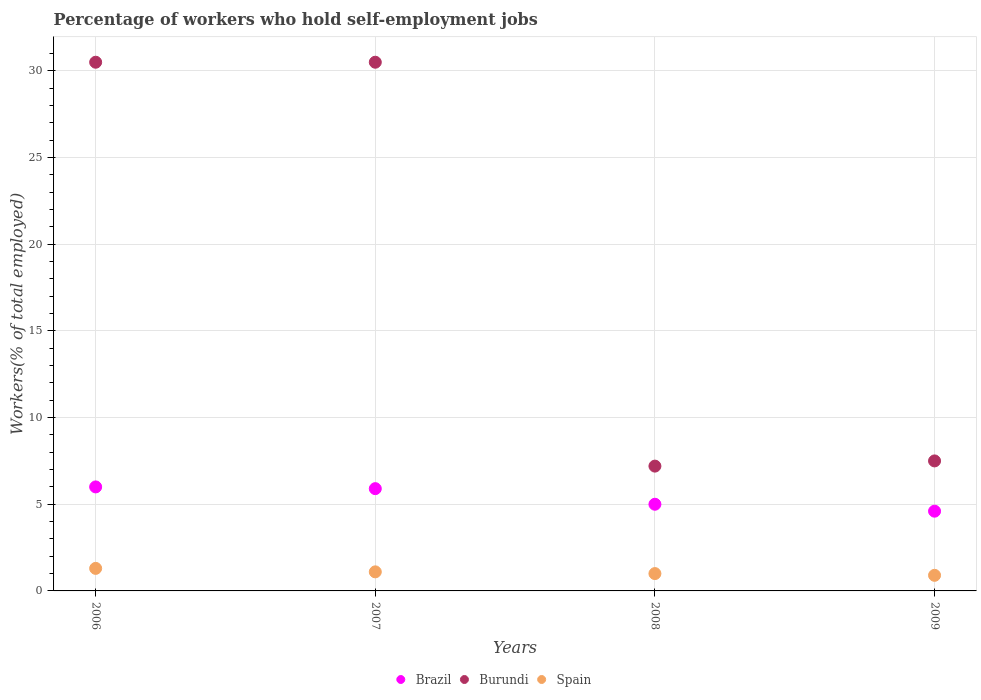Is the number of dotlines equal to the number of legend labels?
Your answer should be very brief. Yes. What is the percentage of self-employed workers in Brazil in 2008?
Give a very brief answer. 5. Across all years, what is the maximum percentage of self-employed workers in Burundi?
Provide a short and direct response. 30.5. Across all years, what is the minimum percentage of self-employed workers in Brazil?
Ensure brevity in your answer.  4.6. In which year was the percentage of self-employed workers in Brazil maximum?
Keep it short and to the point. 2006. In which year was the percentage of self-employed workers in Spain minimum?
Your answer should be very brief. 2009. What is the difference between the percentage of self-employed workers in Brazil in 2008 and that in 2009?
Make the answer very short. 0.4. What is the difference between the percentage of self-employed workers in Brazil in 2008 and the percentage of self-employed workers in Spain in 2009?
Your answer should be very brief. 4.1. What is the average percentage of self-employed workers in Burundi per year?
Your response must be concise. 18.92. In the year 2008, what is the difference between the percentage of self-employed workers in Burundi and percentage of self-employed workers in Spain?
Offer a terse response. 6.2. What is the ratio of the percentage of self-employed workers in Burundi in 2006 to that in 2007?
Provide a short and direct response. 1. Is the difference between the percentage of self-employed workers in Burundi in 2008 and 2009 greater than the difference between the percentage of self-employed workers in Spain in 2008 and 2009?
Ensure brevity in your answer.  No. What is the difference between the highest and the lowest percentage of self-employed workers in Brazil?
Offer a very short reply. 1.4. In how many years, is the percentage of self-employed workers in Burundi greater than the average percentage of self-employed workers in Burundi taken over all years?
Give a very brief answer. 2. Does the percentage of self-employed workers in Brazil monotonically increase over the years?
Offer a very short reply. No. Is the percentage of self-employed workers in Brazil strictly less than the percentage of self-employed workers in Spain over the years?
Provide a short and direct response. No. How many dotlines are there?
Provide a succinct answer. 3. How many years are there in the graph?
Your answer should be very brief. 4. Does the graph contain grids?
Provide a short and direct response. Yes. Where does the legend appear in the graph?
Make the answer very short. Bottom center. How many legend labels are there?
Ensure brevity in your answer.  3. How are the legend labels stacked?
Your answer should be compact. Horizontal. What is the title of the graph?
Provide a succinct answer. Percentage of workers who hold self-employment jobs. What is the label or title of the X-axis?
Your answer should be compact. Years. What is the label or title of the Y-axis?
Provide a short and direct response. Workers(% of total employed). What is the Workers(% of total employed) of Burundi in 2006?
Make the answer very short. 30.5. What is the Workers(% of total employed) in Spain in 2006?
Ensure brevity in your answer.  1.3. What is the Workers(% of total employed) in Brazil in 2007?
Provide a short and direct response. 5.9. What is the Workers(% of total employed) of Burundi in 2007?
Give a very brief answer. 30.5. What is the Workers(% of total employed) in Spain in 2007?
Provide a succinct answer. 1.1. What is the Workers(% of total employed) in Brazil in 2008?
Your answer should be very brief. 5. What is the Workers(% of total employed) in Burundi in 2008?
Ensure brevity in your answer.  7.2. What is the Workers(% of total employed) in Brazil in 2009?
Your response must be concise. 4.6. What is the Workers(% of total employed) of Burundi in 2009?
Keep it short and to the point. 7.5. What is the Workers(% of total employed) of Spain in 2009?
Your response must be concise. 0.9. Across all years, what is the maximum Workers(% of total employed) in Burundi?
Offer a very short reply. 30.5. Across all years, what is the maximum Workers(% of total employed) of Spain?
Ensure brevity in your answer.  1.3. Across all years, what is the minimum Workers(% of total employed) in Brazil?
Your response must be concise. 4.6. Across all years, what is the minimum Workers(% of total employed) of Burundi?
Offer a terse response. 7.2. Across all years, what is the minimum Workers(% of total employed) in Spain?
Offer a very short reply. 0.9. What is the total Workers(% of total employed) in Burundi in the graph?
Give a very brief answer. 75.7. What is the total Workers(% of total employed) of Spain in the graph?
Provide a short and direct response. 4.3. What is the difference between the Workers(% of total employed) of Burundi in 2006 and that in 2007?
Offer a very short reply. 0. What is the difference between the Workers(% of total employed) of Brazil in 2006 and that in 2008?
Give a very brief answer. 1. What is the difference between the Workers(% of total employed) of Burundi in 2006 and that in 2008?
Ensure brevity in your answer.  23.3. What is the difference between the Workers(% of total employed) of Brazil in 2006 and that in 2009?
Make the answer very short. 1.4. What is the difference between the Workers(% of total employed) of Burundi in 2007 and that in 2008?
Offer a terse response. 23.3. What is the difference between the Workers(% of total employed) in Brazil in 2007 and that in 2009?
Make the answer very short. 1.3. What is the difference between the Workers(% of total employed) of Brazil in 2008 and that in 2009?
Your answer should be very brief. 0.4. What is the difference between the Workers(% of total employed) in Spain in 2008 and that in 2009?
Ensure brevity in your answer.  0.1. What is the difference between the Workers(% of total employed) of Brazil in 2006 and the Workers(% of total employed) of Burundi in 2007?
Offer a terse response. -24.5. What is the difference between the Workers(% of total employed) in Brazil in 2006 and the Workers(% of total employed) in Spain in 2007?
Offer a very short reply. 4.9. What is the difference between the Workers(% of total employed) in Burundi in 2006 and the Workers(% of total employed) in Spain in 2007?
Your response must be concise. 29.4. What is the difference between the Workers(% of total employed) in Burundi in 2006 and the Workers(% of total employed) in Spain in 2008?
Ensure brevity in your answer.  29.5. What is the difference between the Workers(% of total employed) in Burundi in 2006 and the Workers(% of total employed) in Spain in 2009?
Your response must be concise. 29.6. What is the difference between the Workers(% of total employed) in Brazil in 2007 and the Workers(% of total employed) in Burundi in 2008?
Give a very brief answer. -1.3. What is the difference between the Workers(% of total employed) in Brazil in 2007 and the Workers(% of total employed) in Spain in 2008?
Your response must be concise. 4.9. What is the difference between the Workers(% of total employed) of Burundi in 2007 and the Workers(% of total employed) of Spain in 2008?
Your answer should be compact. 29.5. What is the difference between the Workers(% of total employed) in Brazil in 2007 and the Workers(% of total employed) in Burundi in 2009?
Give a very brief answer. -1.6. What is the difference between the Workers(% of total employed) in Brazil in 2007 and the Workers(% of total employed) in Spain in 2009?
Your answer should be compact. 5. What is the difference between the Workers(% of total employed) of Burundi in 2007 and the Workers(% of total employed) of Spain in 2009?
Offer a terse response. 29.6. What is the difference between the Workers(% of total employed) in Brazil in 2008 and the Workers(% of total employed) in Burundi in 2009?
Your response must be concise. -2.5. What is the average Workers(% of total employed) in Brazil per year?
Your answer should be very brief. 5.38. What is the average Workers(% of total employed) in Burundi per year?
Provide a succinct answer. 18.93. What is the average Workers(% of total employed) of Spain per year?
Keep it short and to the point. 1.07. In the year 2006, what is the difference between the Workers(% of total employed) of Brazil and Workers(% of total employed) of Burundi?
Give a very brief answer. -24.5. In the year 2006, what is the difference between the Workers(% of total employed) of Brazil and Workers(% of total employed) of Spain?
Give a very brief answer. 4.7. In the year 2006, what is the difference between the Workers(% of total employed) in Burundi and Workers(% of total employed) in Spain?
Keep it short and to the point. 29.2. In the year 2007, what is the difference between the Workers(% of total employed) of Brazil and Workers(% of total employed) of Burundi?
Make the answer very short. -24.6. In the year 2007, what is the difference between the Workers(% of total employed) of Burundi and Workers(% of total employed) of Spain?
Keep it short and to the point. 29.4. In the year 2008, what is the difference between the Workers(% of total employed) in Brazil and Workers(% of total employed) in Spain?
Provide a short and direct response. 4. In the year 2008, what is the difference between the Workers(% of total employed) of Burundi and Workers(% of total employed) of Spain?
Your response must be concise. 6.2. In the year 2009, what is the difference between the Workers(% of total employed) in Brazil and Workers(% of total employed) in Burundi?
Provide a short and direct response. -2.9. In the year 2009, what is the difference between the Workers(% of total employed) in Brazil and Workers(% of total employed) in Spain?
Your answer should be very brief. 3.7. In the year 2009, what is the difference between the Workers(% of total employed) in Burundi and Workers(% of total employed) in Spain?
Your response must be concise. 6.6. What is the ratio of the Workers(% of total employed) of Brazil in 2006 to that in 2007?
Your answer should be compact. 1.02. What is the ratio of the Workers(% of total employed) of Spain in 2006 to that in 2007?
Your answer should be compact. 1.18. What is the ratio of the Workers(% of total employed) of Burundi in 2006 to that in 2008?
Ensure brevity in your answer.  4.24. What is the ratio of the Workers(% of total employed) of Spain in 2006 to that in 2008?
Give a very brief answer. 1.3. What is the ratio of the Workers(% of total employed) in Brazil in 2006 to that in 2009?
Give a very brief answer. 1.3. What is the ratio of the Workers(% of total employed) of Burundi in 2006 to that in 2009?
Your answer should be compact. 4.07. What is the ratio of the Workers(% of total employed) in Spain in 2006 to that in 2009?
Keep it short and to the point. 1.44. What is the ratio of the Workers(% of total employed) in Brazil in 2007 to that in 2008?
Give a very brief answer. 1.18. What is the ratio of the Workers(% of total employed) of Burundi in 2007 to that in 2008?
Make the answer very short. 4.24. What is the ratio of the Workers(% of total employed) of Brazil in 2007 to that in 2009?
Your response must be concise. 1.28. What is the ratio of the Workers(% of total employed) in Burundi in 2007 to that in 2009?
Make the answer very short. 4.07. What is the ratio of the Workers(% of total employed) in Spain in 2007 to that in 2009?
Provide a short and direct response. 1.22. What is the ratio of the Workers(% of total employed) of Brazil in 2008 to that in 2009?
Your answer should be compact. 1.09. What is the difference between the highest and the second highest Workers(% of total employed) of Brazil?
Offer a terse response. 0.1. What is the difference between the highest and the second highest Workers(% of total employed) in Burundi?
Keep it short and to the point. 0. What is the difference between the highest and the lowest Workers(% of total employed) in Burundi?
Offer a very short reply. 23.3. 